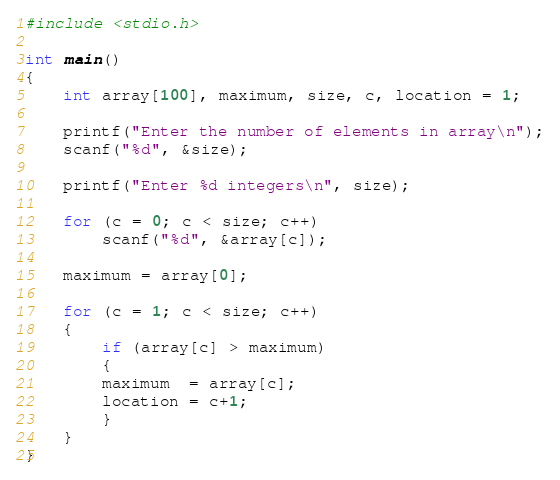Convert code to text. <code><loc_0><loc_0><loc_500><loc_500><_C_>#include <stdio.h>

int main()
{    
    int array[100], maximum, size, c, location = 1;
    
    printf("Enter the number of elements in array\n");
    scanf("%d", &size);
    
    printf("Enter %d integers\n", size);
    
    for (c = 0; c < size; c++)
        scanf("%d", &array[c]);
    
    maximum = array[0];
    
    for (c = 1; c < size; c++)
    {
        if (array[c] > maximum)
        {
        maximum  = array[c];
        location = c+1;
        }
    }
}
</code> 